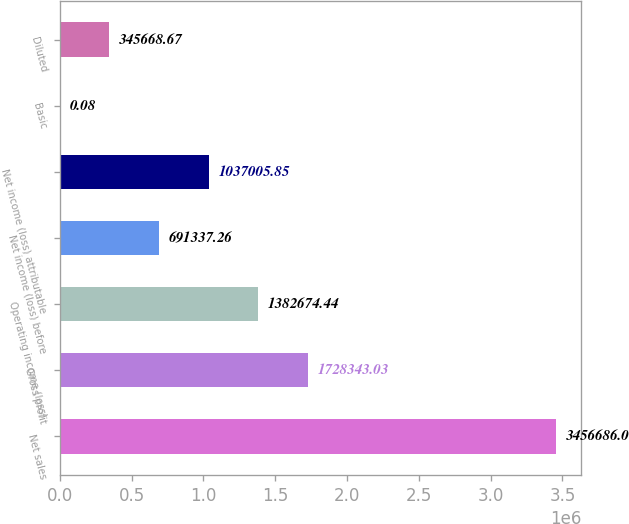Convert chart. <chart><loc_0><loc_0><loc_500><loc_500><bar_chart><fcel>Net sales<fcel>Gross profit<fcel>Operating income (loss)<fcel>Net income (loss) before<fcel>Net income (loss) attributable<fcel>Basic<fcel>Diluted<nl><fcel>3.45669e+06<fcel>1.72834e+06<fcel>1.38267e+06<fcel>691337<fcel>1.03701e+06<fcel>0.08<fcel>345669<nl></chart> 